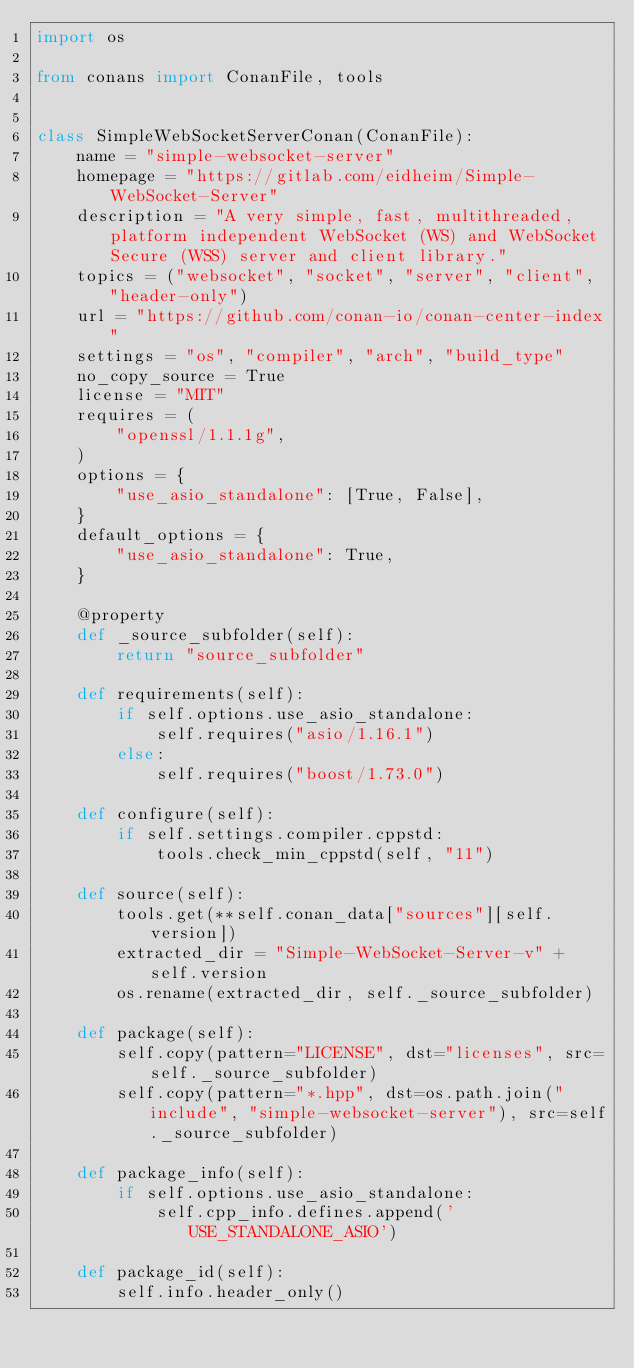<code> <loc_0><loc_0><loc_500><loc_500><_Python_>import os

from conans import ConanFile, tools


class SimpleWebSocketServerConan(ConanFile):
    name = "simple-websocket-server"
    homepage = "https://gitlab.com/eidheim/Simple-WebSocket-Server"
    description = "A very simple, fast, multithreaded, platform independent WebSocket (WS) and WebSocket Secure (WSS) server and client library."
    topics = ("websocket", "socket", "server", "client", "header-only")
    url = "https://github.com/conan-io/conan-center-index"
    settings = "os", "compiler", "arch", "build_type"
    no_copy_source = True
    license = "MIT"
    requires = (
        "openssl/1.1.1g",
    )
    options = {
        "use_asio_standalone": [True, False],
    }
    default_options = {
        "use_asio_standalone": True,
    }

    @property
    def _source_subfolder(self):
        return "source_subfolder"

    def requirements(self):
        if self.options.use_asio_standalone:
            self.requires("asio/1.16.1")
        else:
            self.requires("boost/1.73.0")

    def configure(self):
        if self.settings.compiler.cppstd:
            tools.check_min_cppstd(self, "11")

    def source(self):
        tools.get(**self.conan_data["sources"][self.version])
        extracted_dir = "Simple-WebSocket-Server-v" + self.version
        os.rename(extracted_dir, self._source_subfolder)

    def package(self):
        self.copy(pattern="LICENSE", dst="licenses", src=self._source_subfolder)
        self.copy(pattern="*.hpp", dst=os.path.join("include", "simple-websocket-server"), src=self._source_subfolder)

    def package_info(self):
        if self.options.use_asio_standalone:
            self.cpp_info.defines.append('USE_STANDALONE_ASIO')

    def package_id(self):
        self.info.header_only()
</code> 